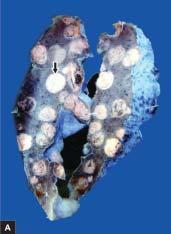does 'triple response ' show replacement of slaty-grey spongy parenchyma with multiple, firm, grey-white nodular masses, some having areas of haemorhages and necrosis?
Answer the question using a single word or phrase. No 